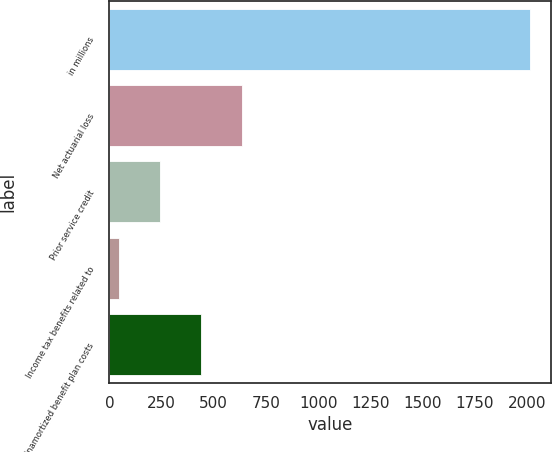<chart> <loc_0><loc_0><loc_500><loc_500><bar_chart><fcel>in millions<fcel>Net actuarial loss<fcel>Prior service credit<fcel>Income tax benefits related to<fcel>Unamortized benefit plan costs<nl><fcel>2013<fcel>634.7<fcel>240.9<fcel>44<fcel>437.8<nl></chart> 